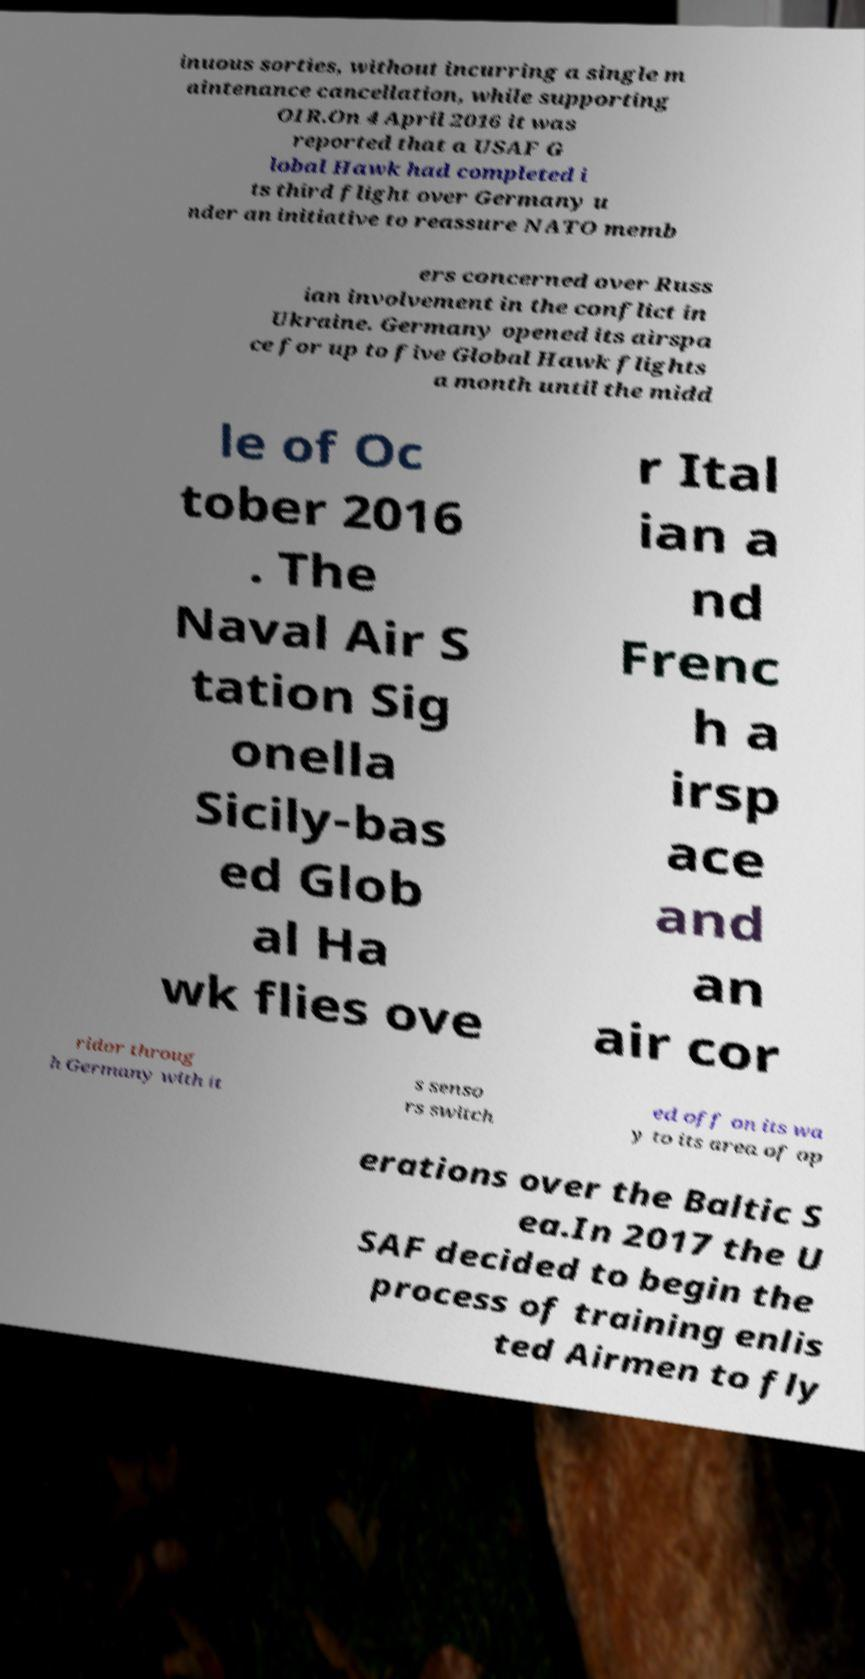There's text embedded in this image that I need extracted. Can you transcribe it verbatim? inuous sorties, without incurring a single m aintenance cancellation, while supporting OIR.On 4 April 2016 it was reported that a USAF G lobal Hawk had completed i ts third flight over Germany u nder an initiative to reassure NATO memb ers concerned over Russ ian involvement in the conflict in Ukraine. Germany opened its airspa ce for up to five Global Hawk flights a month until the midd le of Oc tober 2016 . The Naval Air S tation Sig onella Sicily-bas ed Glob al Ha wk flies ove r Ital ian a nd Frenc h a irsp ace and an air cor ridor throug h Germany with it s senso rs switch ed off on its wa y to its area of op erations over the Baltic S ea.In 2017 the U SAF decided to begin the process of training enlis ted Airmen to fly 